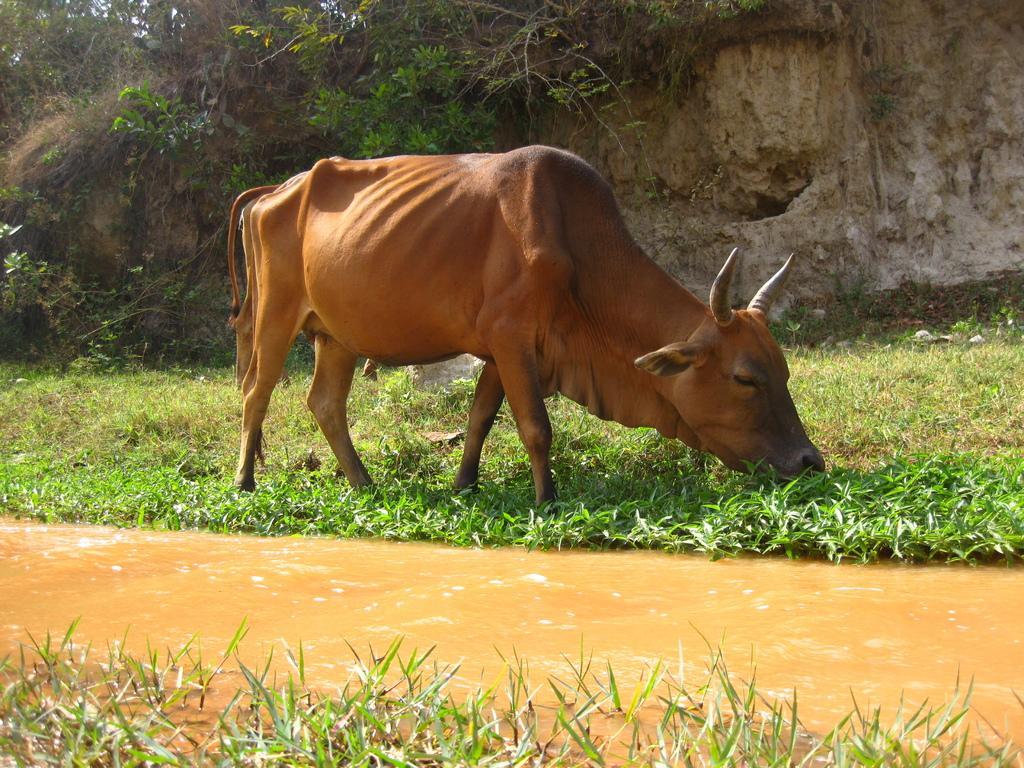How would you summarize this image in a sentence or two? In this image I can see an animal in brown color. I can also see the water. In the background I can see the grass and plants in green color and the sky is in white color. 